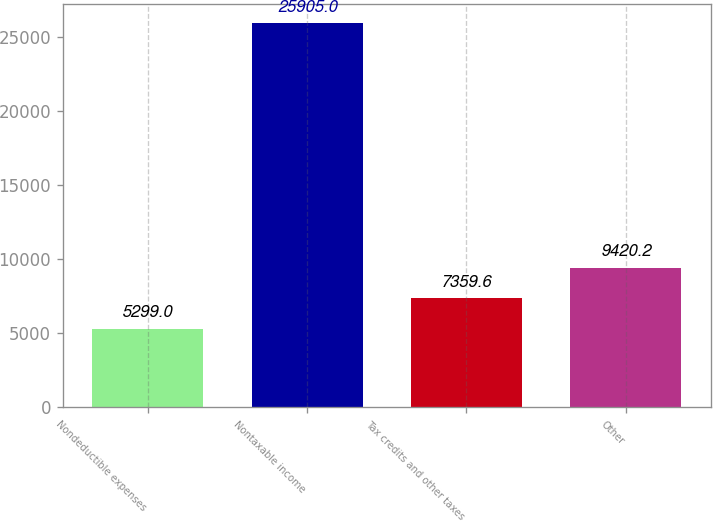<chart> <loc_0><loc_0><loc_500><loc_500><bar_chart><fcel>Nondeductible expenses<fcel>Nontaxable income<fcel>Tax credits and other taxes<fcel>Other<nl><fcel>5299<fcel>25905<fcel>7359.6<fcel>9420.2<nl></chart> 